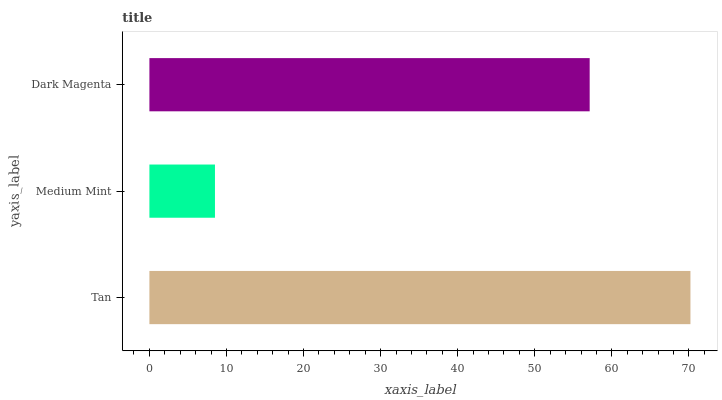Is Medium Mint the minimum?
Answer yes or no. Yes. Is Tan the maximum?
Answer yes or no. Yes. Is Dark Magenta the minimum?
Answer yes or no. No. Is Dark Magenta the maximum?
Answer yes or no. No. Is Dark Magenta greater than Medium Mint?
Answer yes or no. Yes. Is Medium Mint less than Dark Magenta?
Answer yes or no. Yes. Is Medium Mint greater than Dark Magenta?
Answer yes or no. No. Is Dark Magenta less than Medium Mint?
Answer yes or no. No. Is Dark Magenta the high median?
Answer yes or no. Yes. Is Dark Magenta the low median?
Answer yes or no. Yes. Is Medium Mint the high median?
Answer yes or no. No. Is Tan the low median?
Answer yes or no. No. 